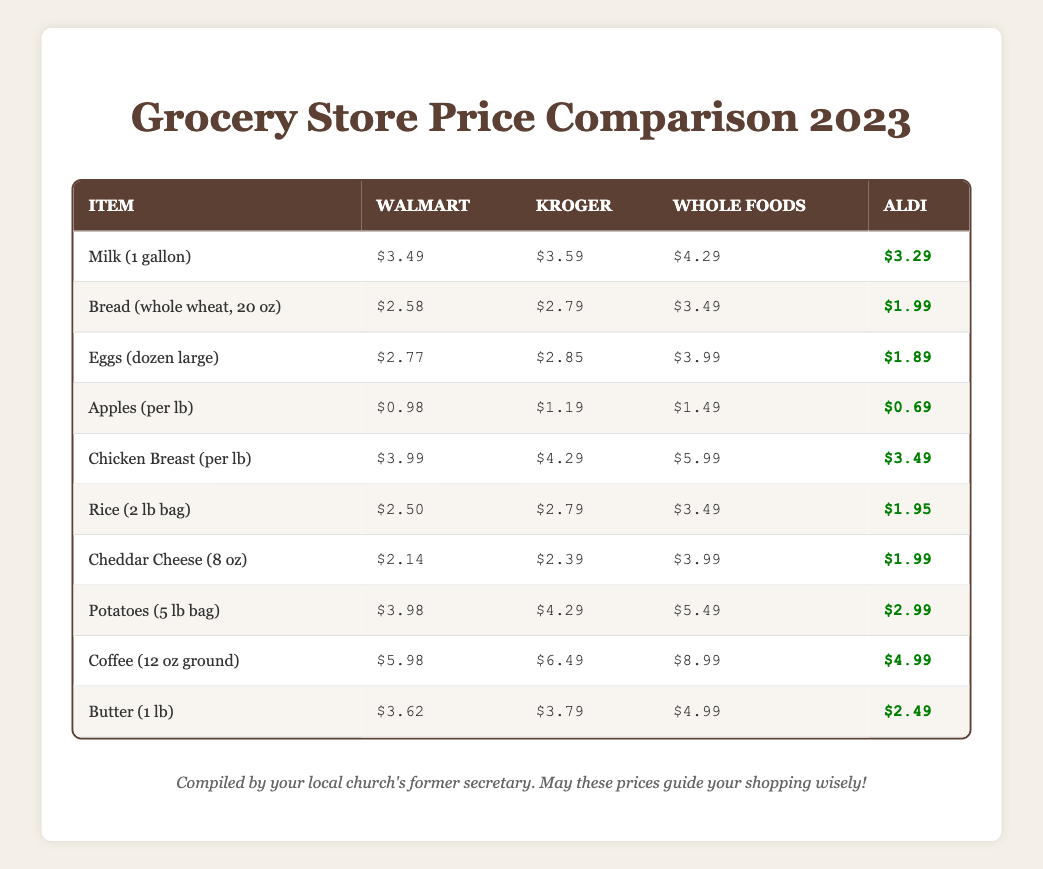What is the price of a dozen large eggs at Aldi? From the table, we can directly see that the price for eggs (dozen large) at Aldi is listed as $1.89.
Answer: $1.89 Which store has the highest price for chicken breast per pound? By examining the table, we find that Whole Foods has the price listed at $5.99, which is higher than other stores (Walmart at $3.99, Kroger at $4.29, and Aldi at $3.49).
Answer: Whole Foods What is the lowest price for rice (2 lb bag) across all stores? The table shows that Aldi sells rice (2 lb bag) for $1.95, which is the lowest price when compared with Walmart $2.50, Kroger $2.79, and Whole Foods $3.49.
Answer: $1.95 If I buy 2 gallons of milk from Walmart and 1 from Aldi, how much will I spend? First, we multiply the price of milk from Walmart, $3.49 by 2, giving $6.98. Then, we take the price from Aldi, $3.29 for 1 gallon. Adding these gives us $6.98 + $3.29 = $10.27 total.
Answer: $10.27 Are all stores selling potatoes at the same price? Looking at the table, different prices for potatoes are visible: Walmart $3.98, Kroger $4.29, Whole Foods $5.49, and Aldi $2.99. Since the prices vary among stores, the answer is no.
Answer: No What is the average price of bread across the four grocery stores? To find the average price, we add Walmart $2.58, Kroger $2.79, Whole Foods $3.49, and Aldi $1.99. The sum is $2.58 + $2.79 + $3.49 + $1.99 = $10.85. Dividing this by the number of stores (4) gives us $10.85 / 4 = $2.71.
Answer: $2.71 Which item has the least price difference between the lowest and highest price across the stores? By evaluating the price differences, we find the smallest difference is for cheddar cheese: Aldi $1.99 and Kroger $2.39, making the difference $2.39 - $1.99 = $0.40. Other items have larger differences.
Answer: Cheddar Cheese What is the total cost of buying 5 lbs of potatoes from Aldi? The price of potatoes at Aldi is $2.99 for a 5 lb bag. Since only one bag is purchased, the cost remains the same, making it straightforward with no additional calculations needed.
Answer: $2.99 Is it cheaper to buy coffee at Whole Foods than at Aldi? The prices for coffee are $8.99 at Whole Foods and $4.99 at Aldi. Since $4.99 is less than $8.99, Aldi is cheaper.
Answer: No 